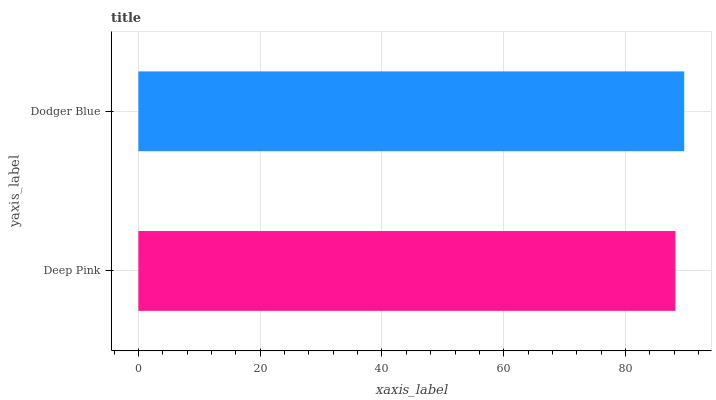Is Deep Pink the minimum?
Answer yes or no. Yes. Is Dodger Blue the maximum?
Answer yes or no. Yes. Is Dodger Blue the minimum?
Answer yes or no. No. Is Dodger Blue greater than Deep Pink?
Answer yes or no. Yes. Is Deep Pink less than Dodger Blue?
Answer yes or no. Yes. Is Deep Pink greater than Dodger Blue?
Answer yes or no. No. Is Dodger Blue less than Deep Pink?
Answer yes or no. No. Is Dodger Blue the high median?
Answer yes or no. Yes. Is Deep Pink the low median?
Answer yes or no. Yes. Is Deep Pink the high median?
Answer yes or no. No. Is Dodger Blue the low median?
Answer yes or no. No. 